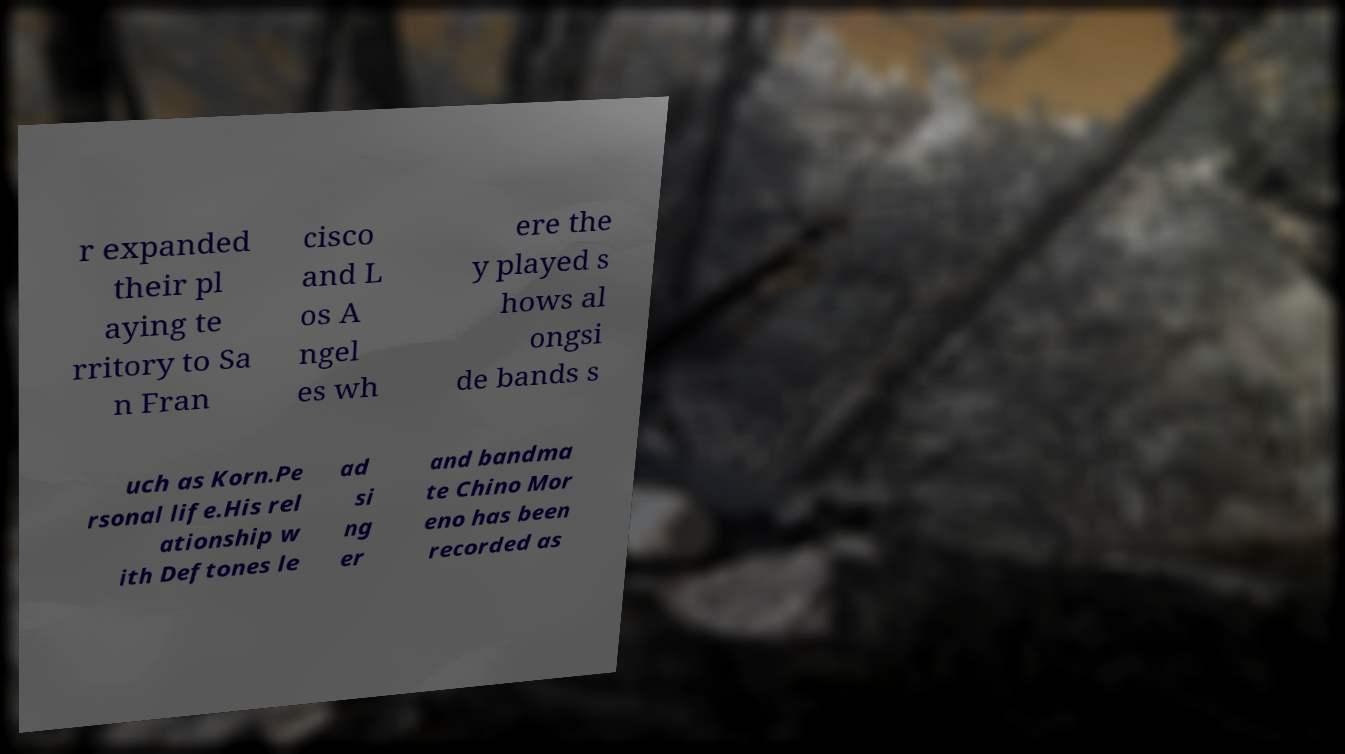Could you assist in decoding the text presented in this image and type it out clearly? r expanded their pl aying te rritory to Sa n Fran cisco and L os A ngel es wh ere the y played s hows al ongsi de bands s uch as Korn.Pe rsonal life.His rel ationship w ith Deftones le ad si ng er and bandma te Chino Mor eno has been recorded as 